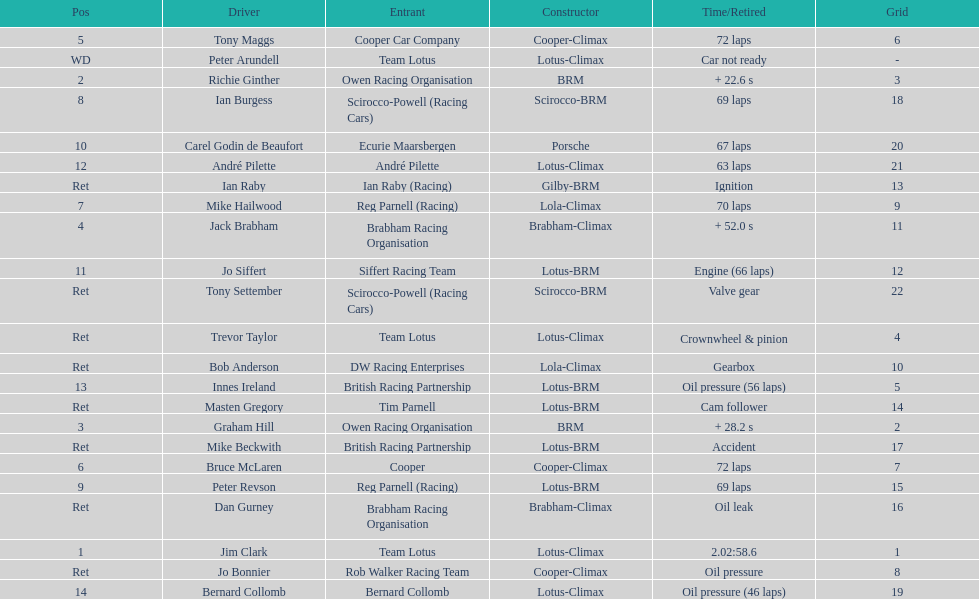What country had the least number of drivers, germany or the uk? Germany. 